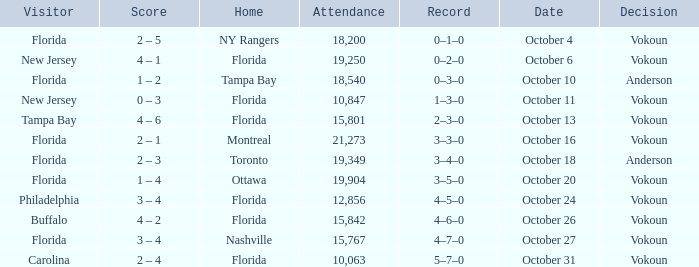Which team won when the visitor was Carolina? Vokoun. 